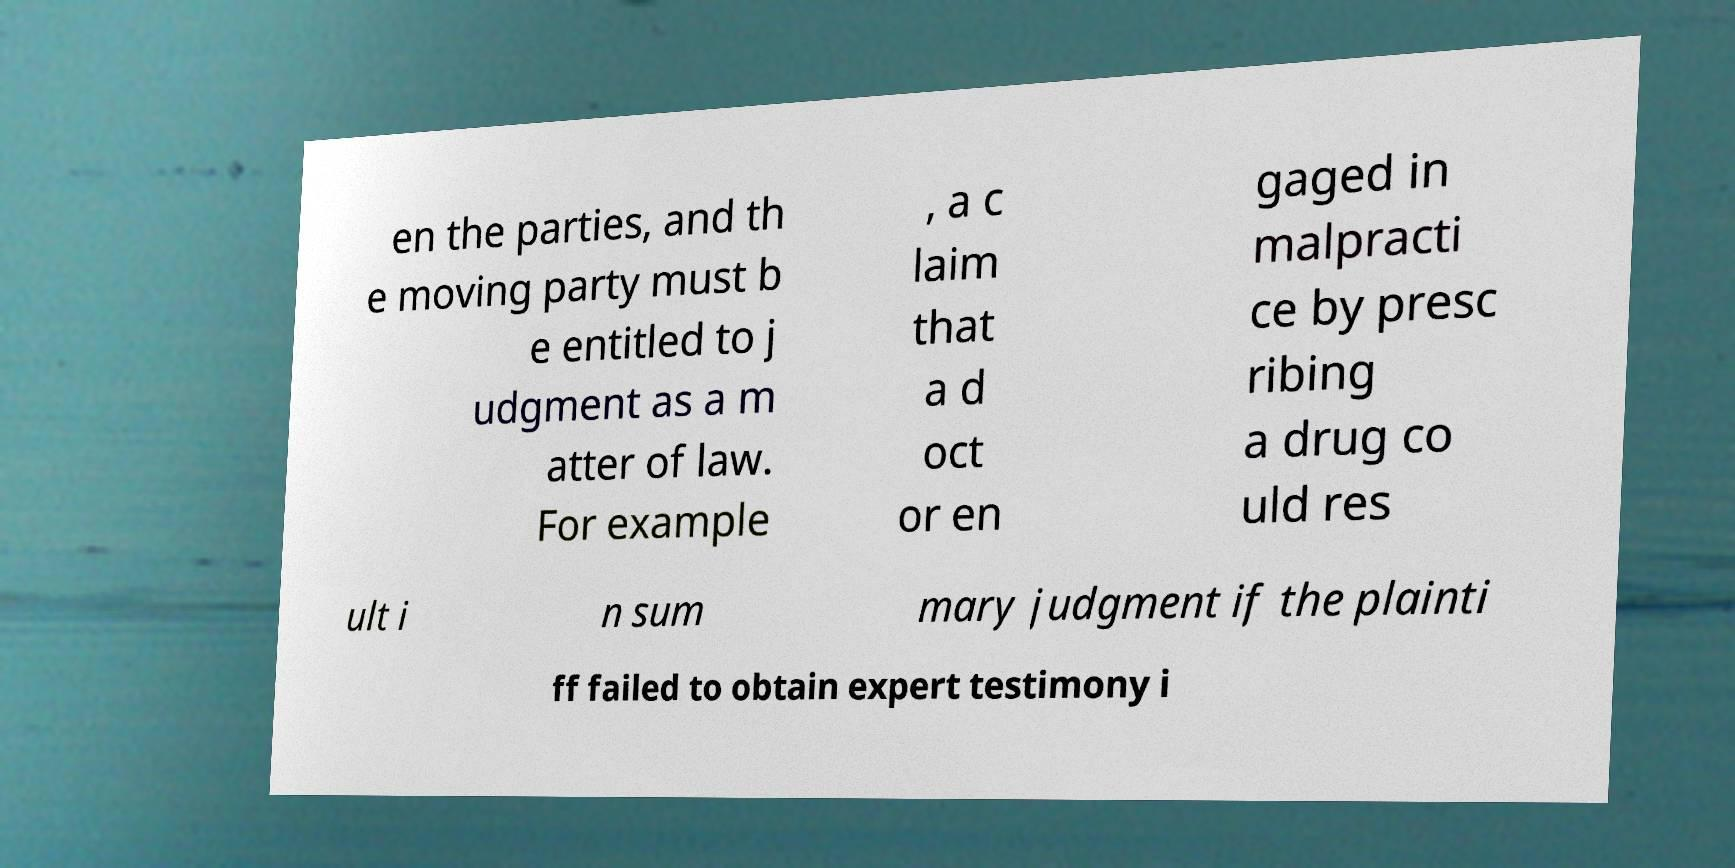Can you accurately transcribe the text from the provided image for me? en the parties, and th e moving party must b e entitled to j udgment as a m atter of law. For example , a c laim that a d oct or en gaged in malpracti ce by presc ribing a drug co uld res ult i n sum mary judgment if the plainti ff failed to obtain expert testimony i 